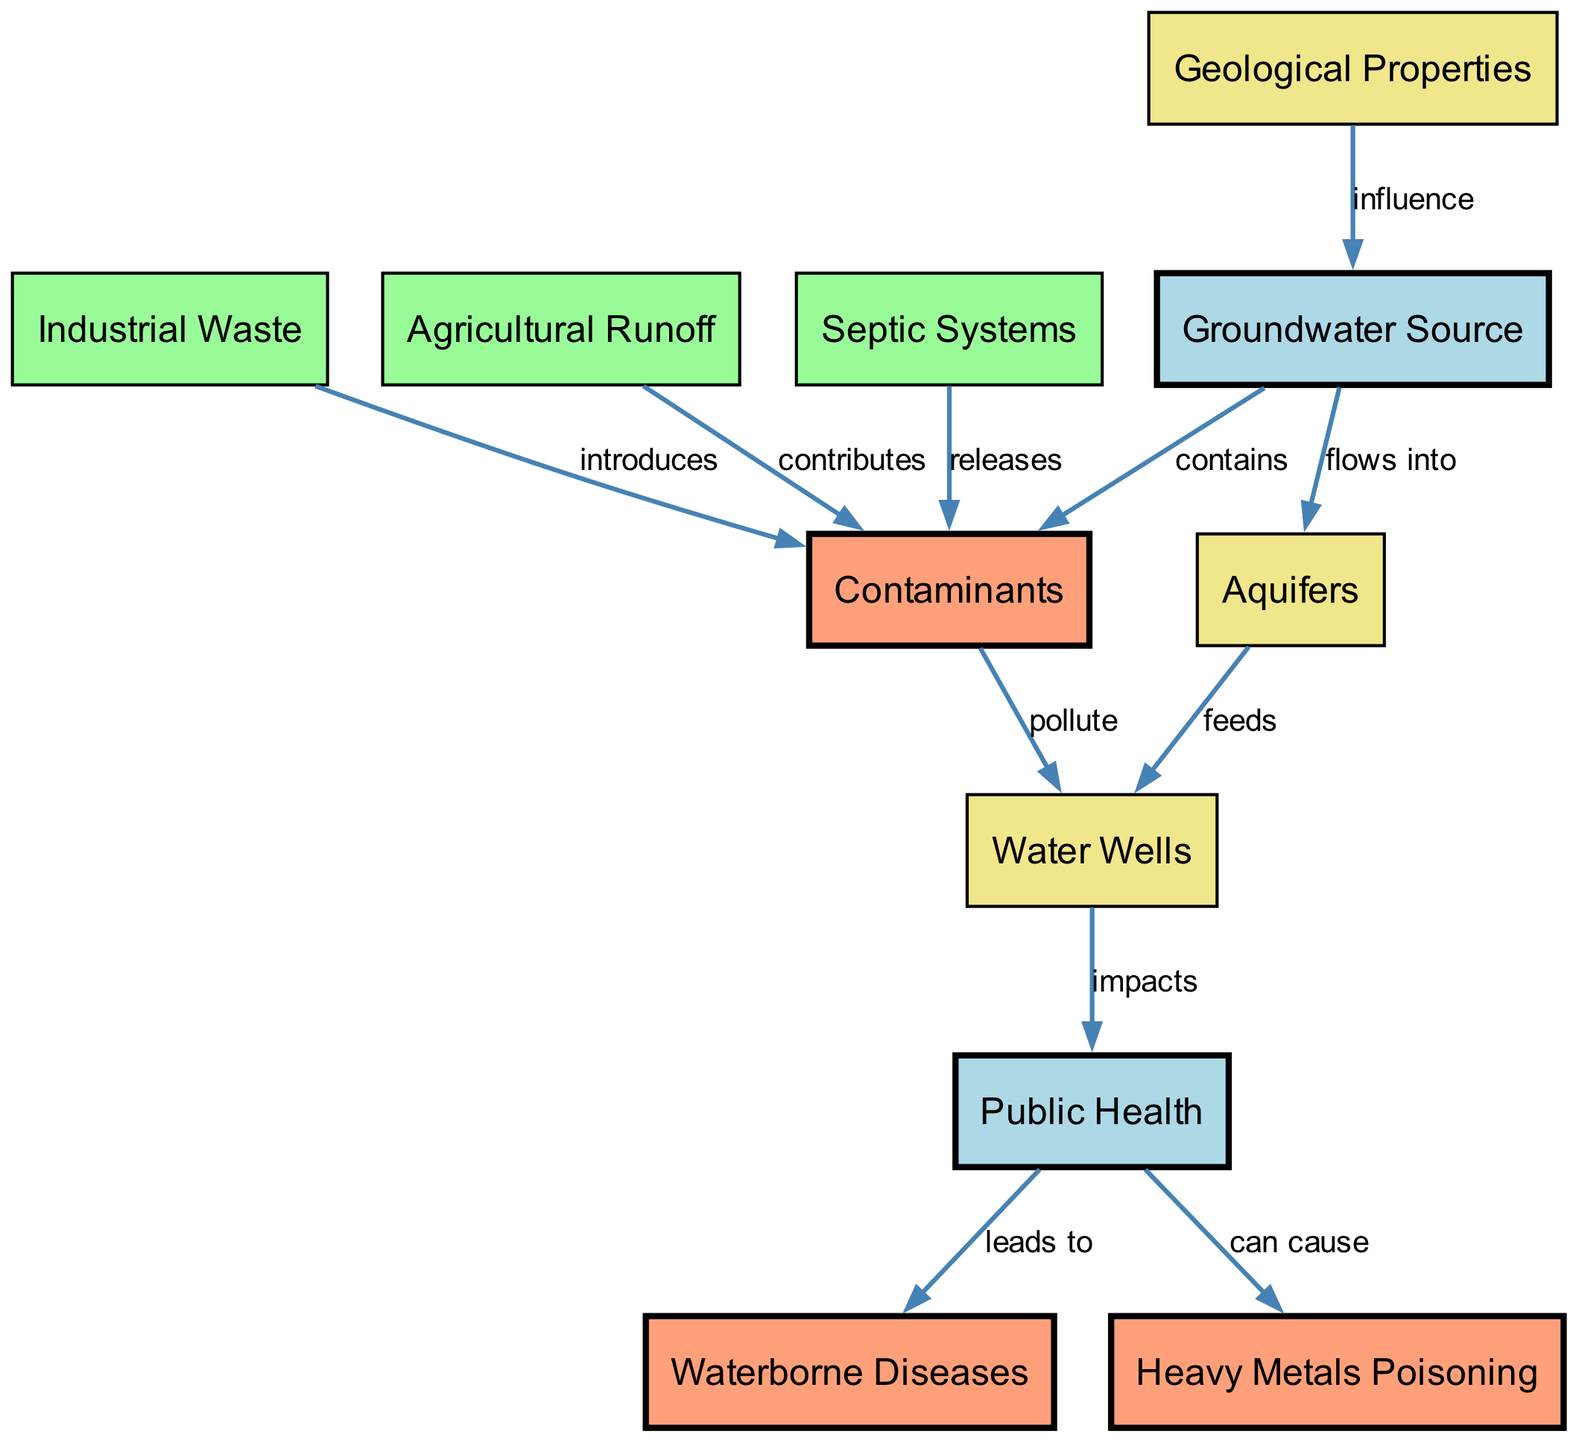What is the first node in the diagram? The first node listed in the diagram is “Groundwater Source.” This is a descriptive query about the diagram's sequence, and since the nodes are presented in a predetermined order, the first one will always be the initial node as defined.
Answer: Groundwater Source How many contaminants are introduced by industrial waste? According to the diagram, "Industrial Waste" introduces contaminants but does not specify the number of contaminants. However, it is the only direct source indicated for this relationship, so the abstract consideration of "contaminants" could be interpreted as at least one. Thus, while the question references a specific number, the information is quite limited.
Answer: At least one What do contaminants in water wells impact? The diagram shows an edge labeled "impacts" from "Water Wells" to "Public Health." Thus, the relationship indicates that contaminants indeed have an impact on public health. The wording in the diagram confirms this direct connection and shows the flow of information seamlessly.
Answer: Public Health Which node leads to waterborne diseases? The diagram outlines a direct relationship between "Public Health" and "Waterborne Diseases," specifically indicating that public health conditions lead to the occurrence of these diseases. This stems from the logical flow in the diagram that connects all components surrounding public health outcomes.
Answer: Waterborne Diseases How do septic systems contribute to contaminants? The diagram clearly highlights that "Septic Systems" release contaminants into the groundwater. This relationship is essential to understand the sources of pollution affecting water quality. By synthesizing the information from the connecting edges, we find septic systems play a role in contaminating groundwater.
Answer: Releases What is the effect of geological properties on groundwater sources? The "Geological Properties" node influences the "Groundwater Source" as stated by the labeled edge "influence." This implies that geological characteristics can determine the quality, quantity, and flow patterns of groundwater. This relationship reflects how natural factors affect groundwater systems directly.
Answer: Influence What are the potential outcomes of contaminants on public health? The diagram suggests two potential health impacts from "Public Health" which are "Waterborne Diseases" and "Heavy Metals Poisoning." This indicates that contamination in water sources can lead to serious health conditions. Both conditions stem from the contamination chain illustrated in the diagram.
Answer: Waterborne Diseases and Heavy Metals Poisoning Which node is affected by industrial waste and agricultural runoff? "Contaminants" is directly affected by both "Industrial Waste" and "Agricultural Runoff," as the diagram indicates that these sources contribute to or introduce contaminants into the groundwater. By examining the edges leading from these sources, we can conclude that they both play roles in contaminating water supplies.
Answer: Contaminants What flows into aquifers from the groundwater source? According to the diagram, the edge "flows into" indicates that "Groundwater Source" supplies water to "Aquifers." This relationship denotes a direct movement of groundwater that enhances aquifer vitality. Understanding the flow process is crucial in interpreting groundwater dynamics in the context of overall water availability.
Answer: Aquifers 